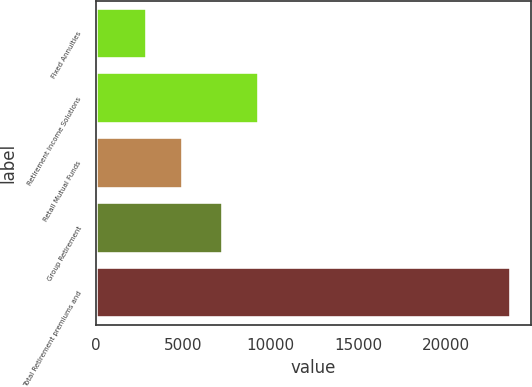<chart> <loc_0><loc_0><loc_500><loc_500><bar_chart><fcel>Fixed Annuities<fcel>Retirement Income Solutions<fcel>Retail Mutual Funds<fcel>Group Retirement<fcel>Total Retirement premiums and<nl><fcel>2914<fcel>9332.5<fcel>4995.5<fcel>7251<fcel>23729<nl></chart> 